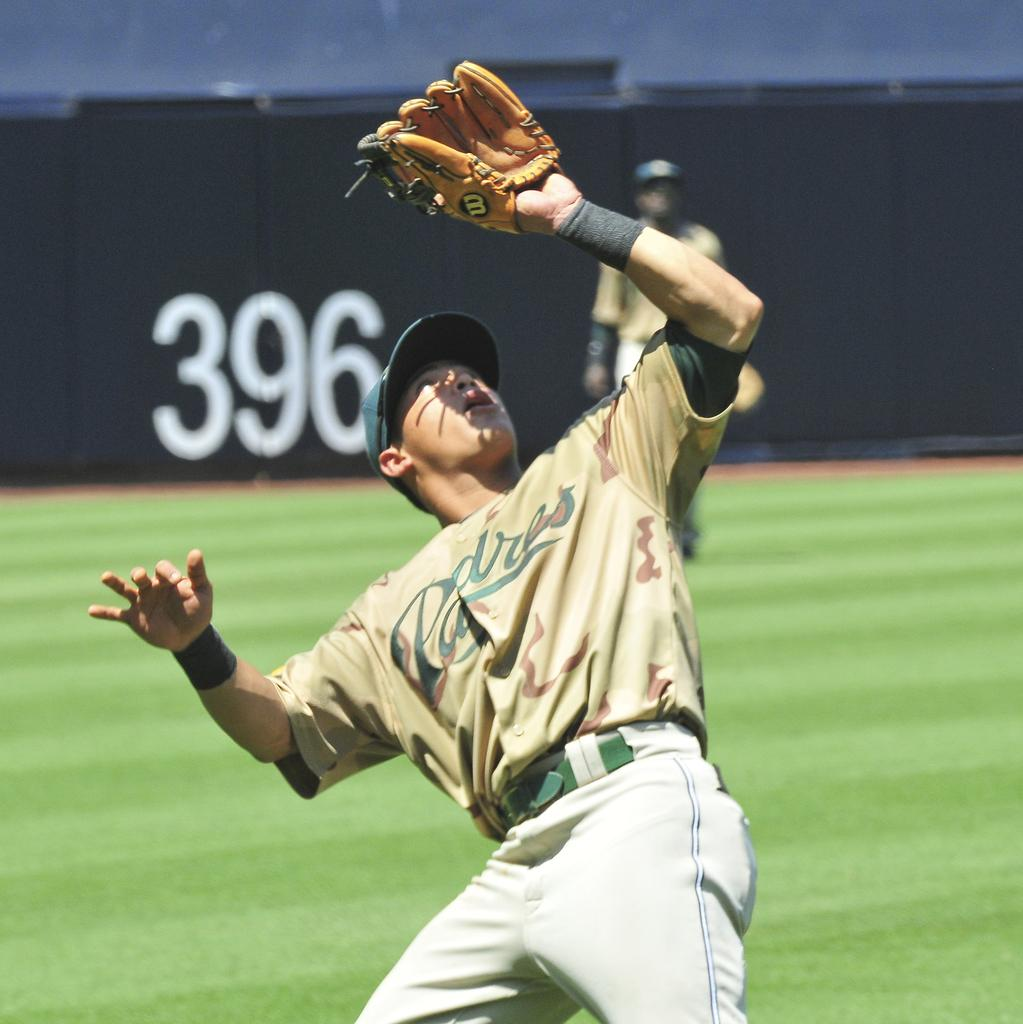<image>
Present a compact description of the photo's key features. A man in a Padres baseball uniform looks to catch the ball. 